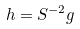<formula> <loc_0><loc_0><loc_500><loc_500>h = S ^ { - 2 } g</formula> 